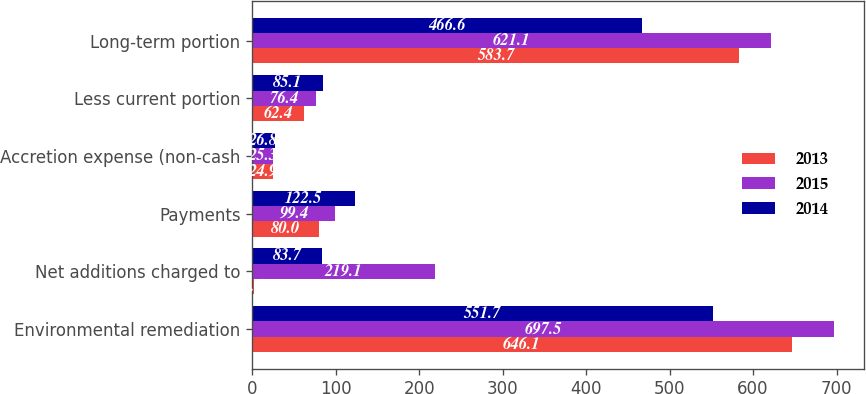Convert chart to OTSL. <chart><loc_0><loc_0><loc_500><loc_500><stacked_bar_chart><ecel><fcel>Environmental remediation<fcel>Net additions charged to<fcel>Payments<fcel>Accretion expense (non-cash<fcel>Less current portion<fcel>Long-term portion<nl><fcel>2013<fcel>646.1<fcel>1.6<fcel>80<fcel>24.9<fcel>62.4<fcel>583.7<nl><fcel>2015<fcel>697.5<fcel>219.1<fcel>99.4<fcel>25.3<fcel>76.4<fcel>621.1<nl><fcel>2014<fcel>551.7<fcel>83.7<fcel>122.5<fcel>26.8<fcel>85.1<fcel>466.6<nl></chart> 